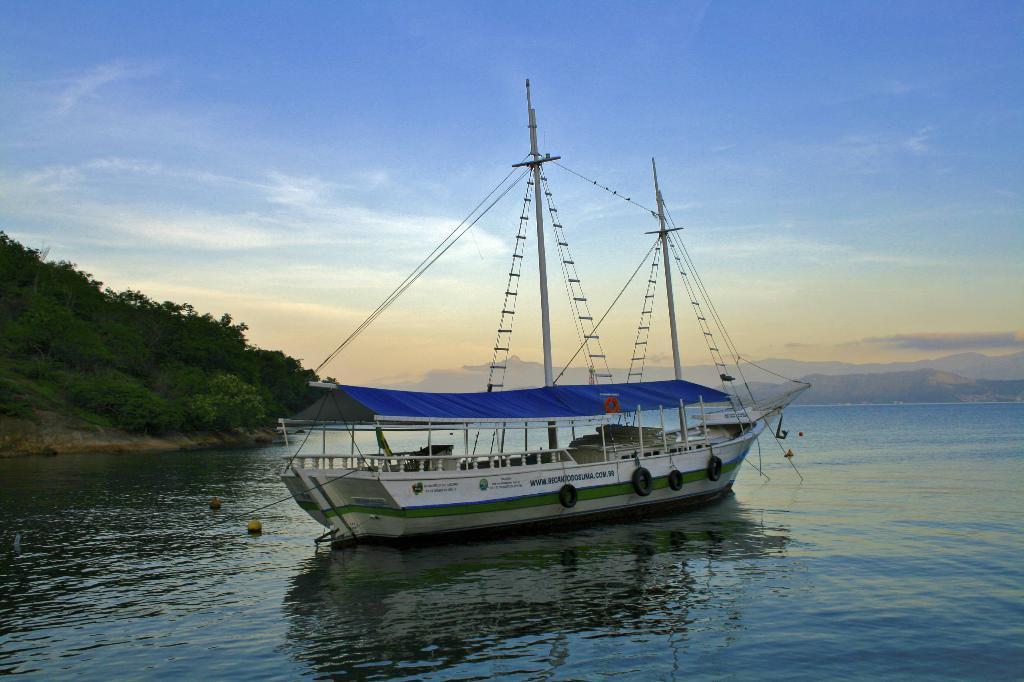Describe this image in one or two sentences. In this picture, we can see water, and some objects on the water, boat with poles, wires, and we can see the ground, plants, mountains, and the sky with clouds. 